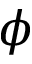<formula> <loc_0><loc_0><loc_500><loc_500>\phi</formula> 